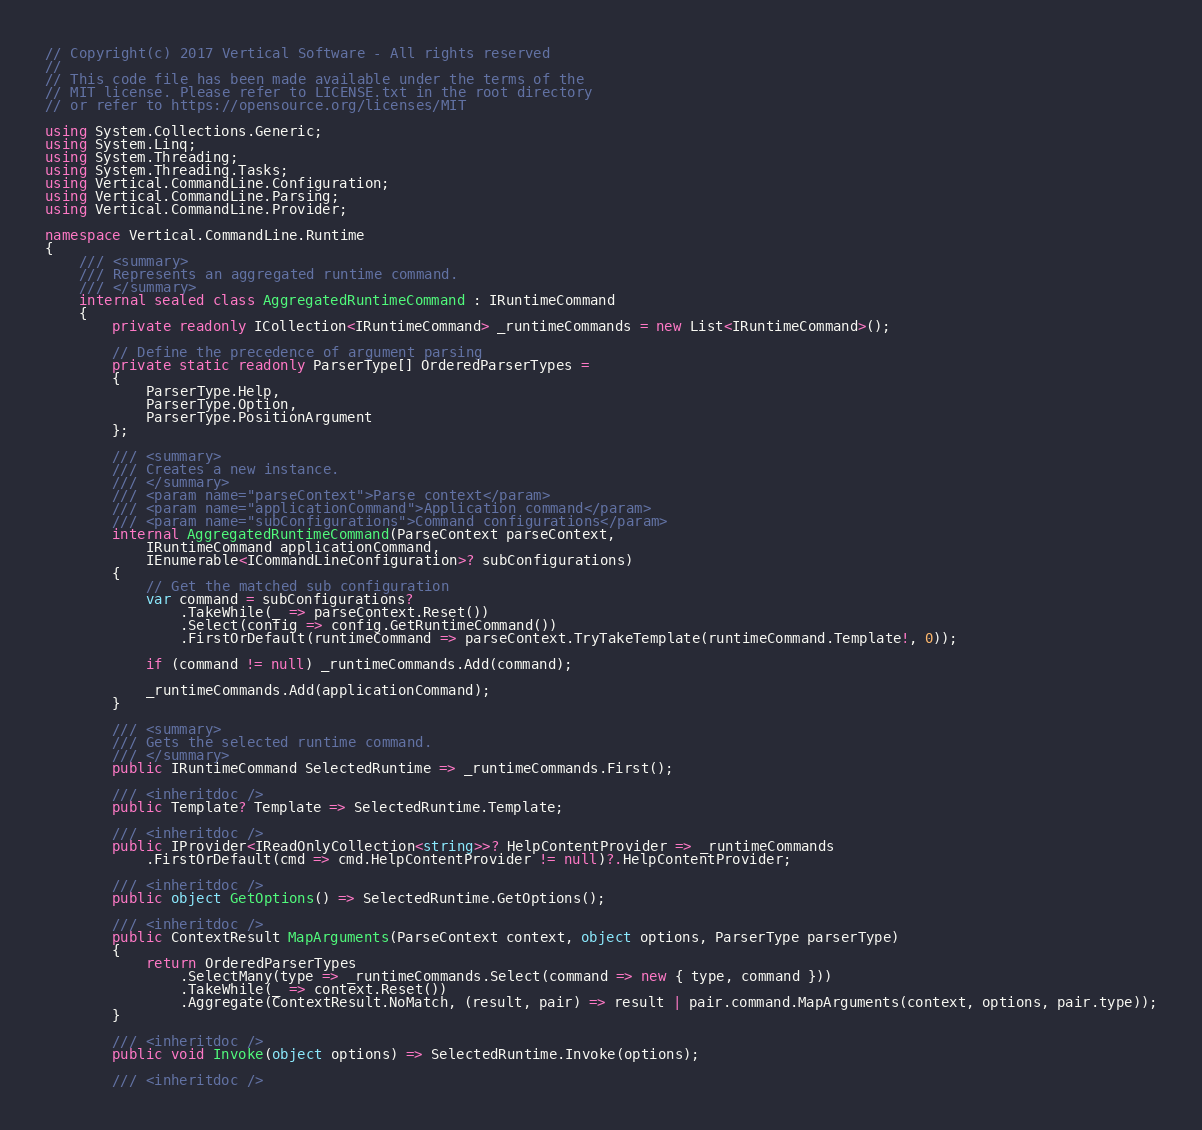<code> <loc_0><loc_0><loc_500><loc_500><_C#_>// Copyright(c) 2017 Vertical Software - All rights reserved
//
// This code file has been made available under the terms of the
// MIT license. Please refer to LICENSE.txt in the root directory
// or refer to https://opensource.org/licenses/MIT

using System.Collections.Generic;
using System.Linq;
using System.Threading;
using System.Threading.Tasks;
using Vertical.CommandLine.Configuration;
using Vertical.CommandLine.Parsing;
using Vertical.CommandLine.Provider;

namespace Vertical.CommandLine.Runtime
{
    /// <summary>
    /// Represents an aggregated runtime command.
    /// </summary>
    internal sealed class AggregatedRuntimeCommand : IRuntimeCommand
    {
        private readonly ICollection<IRuntimeCommand> _runtimeCommands = new List<IRuntimeCommand>();

        // Define the precedence of argument parsing
        private static readonly ParserType[] OrderedParserTypes = 
        {
            ParserType.Help,
            ParserType.Option,
            ParserType.PositionArgument
        };

        /// <summary>
        /// Creates a new instance.
        /// </summary>
        /// <param name="parseContext">Parse context</param>
        /// <param name="applicationCommand">Application command</param>
        /// <param name="subConfigurations">Command configurations</param>
        internal AggregatedRuntimeCommand(ParseContext parseContext,
            IRuntimeCommand applicationCommand,
            IEnumerable<ICommandLineConfiguration>? subConfigurations)
        {
            // Get the matched sub configuration
            var command = subConfigurations?
                .TakeWhile(_ => parseContext.Reset())
                .Select(config => config.GetRuntimeCommand())
                .FirstOrDefault(runtimeCommand => parseContext.TryTakeTemplate(runtimeCommand.Template!, 0));

            if (command != null) _runtimeCommands.Add(command);

            _runtimeCommands.Add(applicationCommand);
        }

        /// <summary>
        /// Gets the selected runtime command.
        /// </summary>
        public IRuntimeCommand SelectedRuntime => _runtimeCommands.First();

        /// <inheritdoc />
        public Template? Template => SelectedRuntime.Template;

        /// <inheritdoc />
        public IProvider<IReadOnlyCollection<string>>? HelpContentProvider => _runtimeCommands
            .FirstOrDefault(cmd => cmd.HelpContentProvider != null)?.HelpContentProvider;

        /// <inheritdoc />
        public object GetOptions() => SelectedRuntime.GetOptions();

        /// <inheritdoc />
        public ContextResult MapArguments(ParseContext context, object options, ParserType parserType)
        {
            return OrderedParserTypes
                .SelectMany(type => _runtimeCommands.Select(command => new { type, command }))
                .TakeWhile(_ => context.Reset())
                .Aggregate(ContextResult.NoMatch, (result, pair) => result | pair.command.MapArguments(context, options, pair.type));
        }

        /// <inheritdoc />
        public void Invoke(object options) => SelectedRuntime.Invoke(options);

        /// <inheritdoc /></code> 